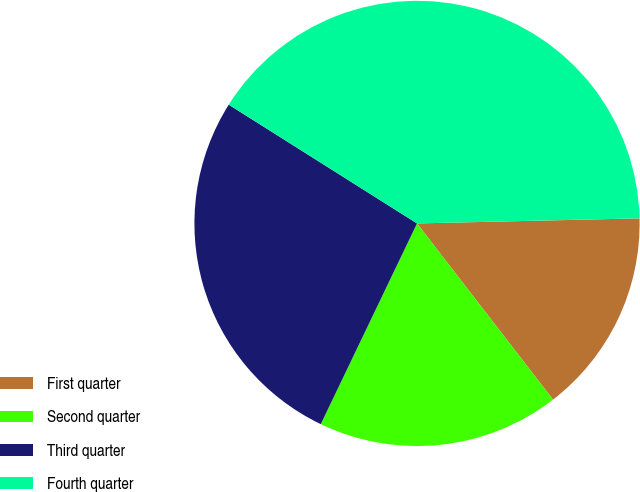Convert chart to OTSL. <chart><loc_0><loc_0><loc_500><loc_500><pie_chart><fcel>First quarter<fcel>Second quarter<fcel>Third quarter<fcel>Fourth quarter<nl><fcel>14.9%<fcel>17.58%<fcel>26.84%<fcel>40.68%<nl></chart> 